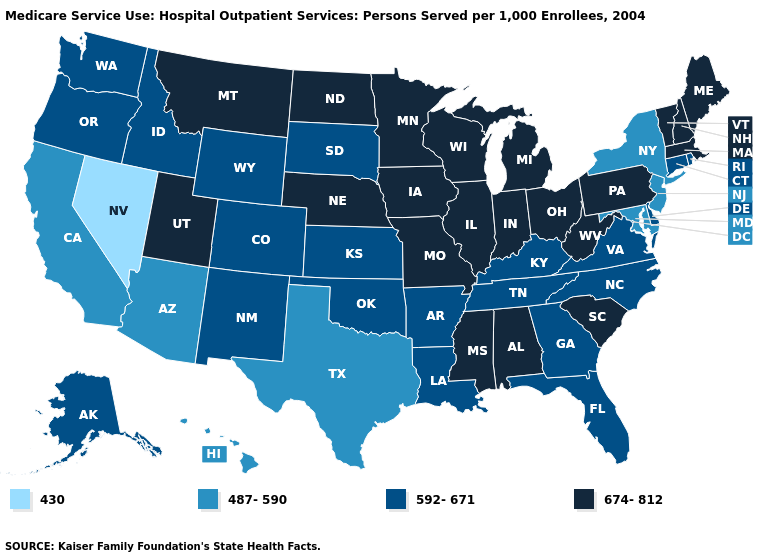What is the value of West Virginia?
Short answer required. 674-812. Does North Carolina have the lowest value in the South?
Write a very short answer. No. Does the map have missing data?
Be succinct. No. What is the lowest value in the Northeast?
Quick response, please. 487-590. Does Vermont have the highest value in the Northeast?
Give a very brief answer. Yes. What is the highest value in the USA?
Answer briefly. 674-812. What is the value of Florida?
Answer briefly. 592-671. Among the states that border New Mexico , which have the lowest value?
Quick response, please. Arizona, Texas. Does West Virginia have the highest value in the South?
Concise answer only. Yes. Does Oregon have the highest value in the West?
Give a very brief answer. No. What is the value of North Dakota?
Answer briefly. 674-812. Does Illinois have the lowest value in the MidWest?
Be succinct. No. Does New Hampshire have a higher value than Montana?
Keep it brief. No. Does California have a higher value than Nevada?
Concise answer only. Yes. Name the states that have a value in the range 674-812?
Quick response, please. Alabama, Illinois, Indiana, Iowa, Maine, Massachusetts, Michigan, Minnesota, Mississippi, Missouri, Montana, Nebraska, New Hampshire, North Dakota, Ohio, Pennsylvania, South Carolina, Utah, Vermont, West Virginia, Wisconsin. 